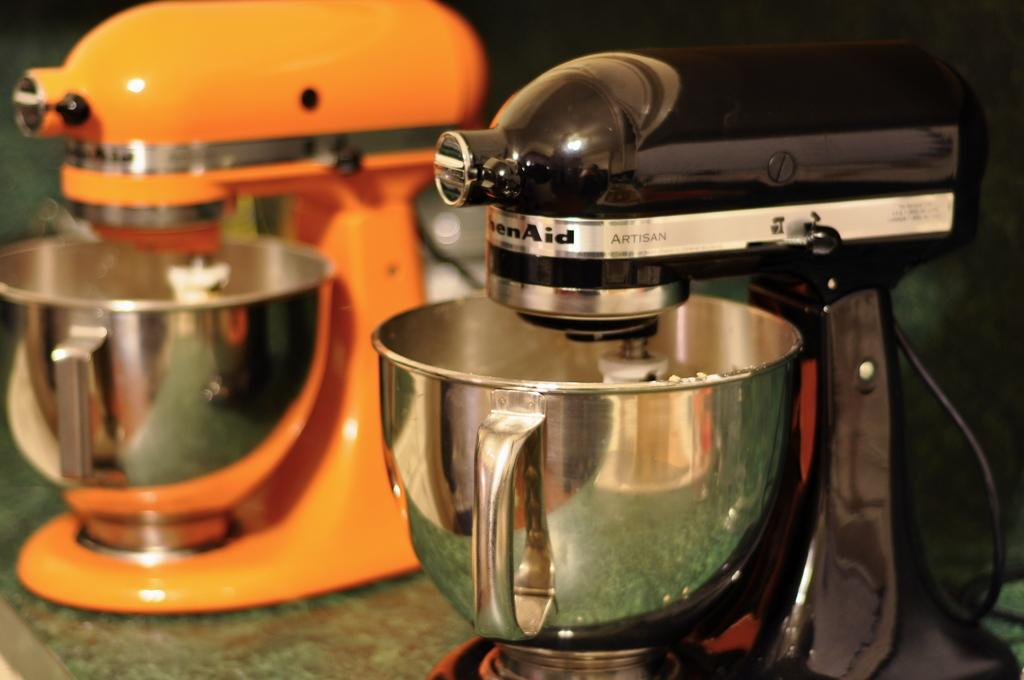<image>
Summarize the visual content of the image. Kitchenaid mixers orange and black are mixing in two stainless steel bowls. 